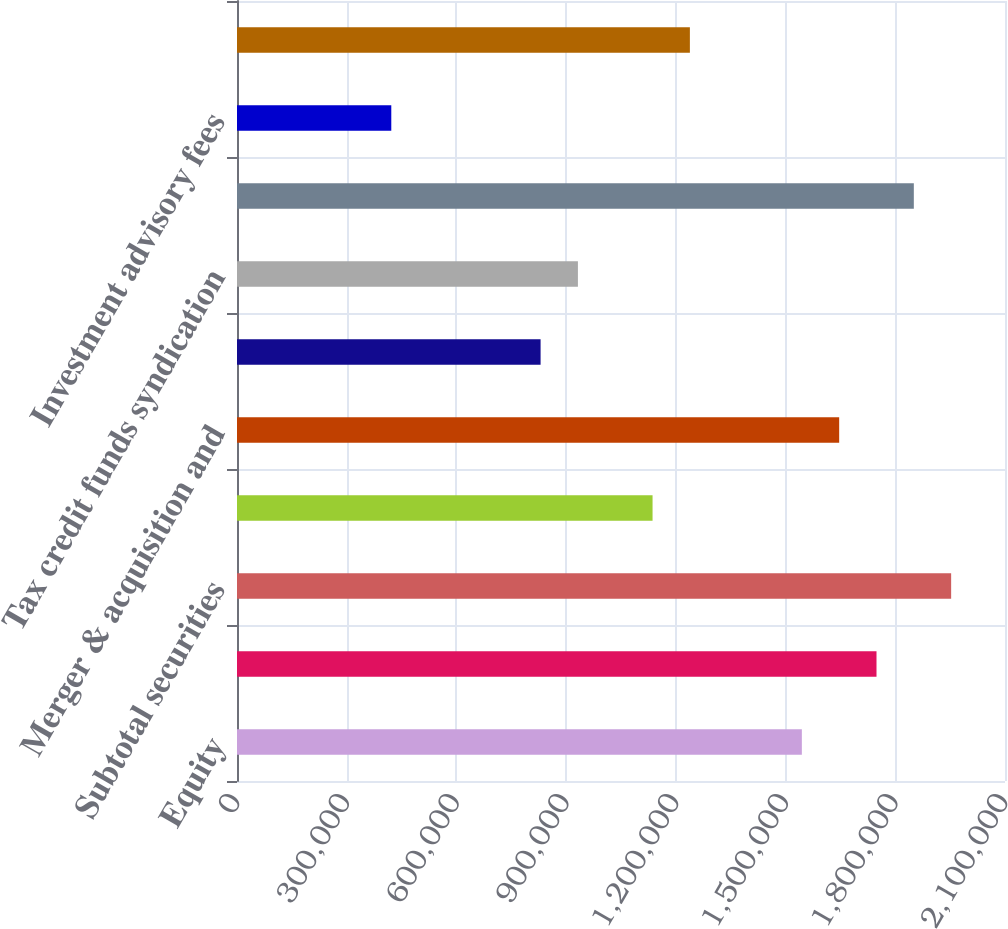<chart> <loc_0><loc_0><loc_500><loc_500><bar_chart><fcel>Equity<fcel>Fixed income<fcel>Subtotal securities<fcel>Equity underwriting fees<fcel>Merger & acquisition and<fcel>Fixed income investment<fcel>Tax credit funds syndication<fcel>Subtotal investment banking<fcel>Investment advisory fees<fcel>Net trading profit<nl><fcel>1.54452e+06<fcel>1.74864e+06<fcel>1.95275e+06<fcel>1.13629e+06<fcel>1.64658e+06<fcel>830121<fcel>932178<fcel>1.85069e+06<fcel>421892<fcel>1.23835e+06<nl></chart> 